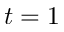<formula> <loc_0><loc_0><loc_500><loc_500>t = 1</formula> 